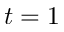<formula> <loc_0><loc_0><loc_500><loc_500>t = 1</formula> 